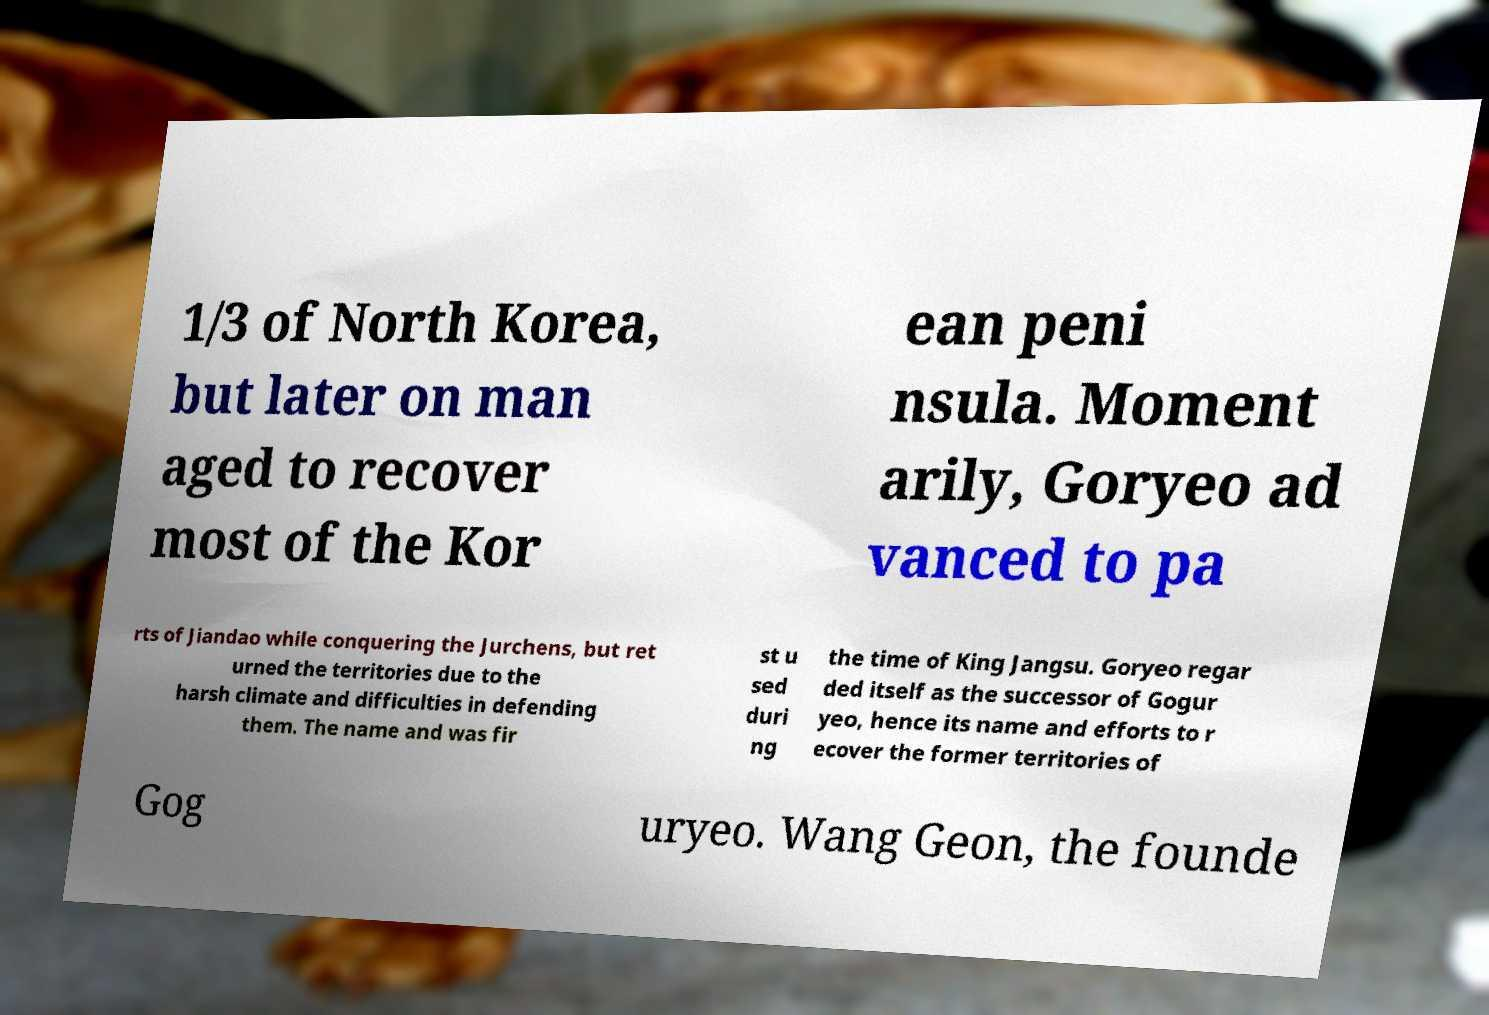Can you read and provide the text displayed in the image?This photo seems to have some interesting text. Can you extract and type it out for me? 1/3 of North Korea, but later on man aged to recover most of the Kor ean peni nsula. Moment arily, Goryeo ad vanced to pa rts of Jiandao while conquering the Jurchens, but ret urned the territories due to the harsh climate and difficulties in defending them. The name and was fir st u sed duri ng the time of King Jangsu. Goryeo regar ded itself as the successor of Gogur yeo, hence its name and efforts to r ecover the former territories of Gog uryeo. Wang Geon, the founde 